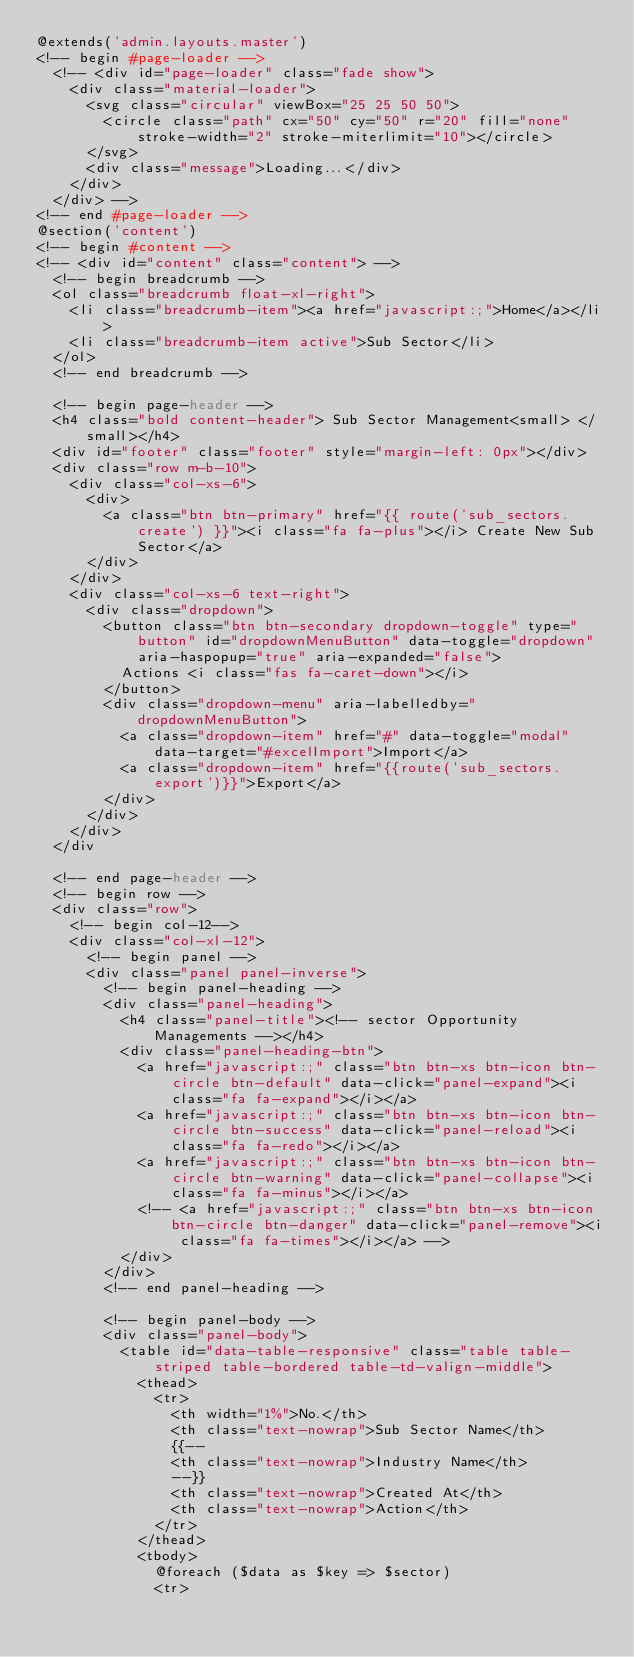Convert code to text. <code><loc_0><loc_0><loc_500><loc_500><_PHP_>@extends('admin.layouts.master')
<!-- begin #page-loader -->
  <!-- <div id="page-loader" class="fade show">
    <div class="material-loader">
      <svg class="circular" viewBox="25 25 50 50">
        <circle class="path" cx="50" cy="50" r="20" fill="none" stroke-width="2" stroke-miterlimit="10"></circle>
      </svg>
      <div class="message">Loading...</div>
    </div>
  </div> -->
<!-- end #page-loader -->
@section('content')
<!-- begin #content -->
<!-- <div id="content" class="content"> -->
  <!-- begin breadcrumb -->
  <ol class="breadcrumb float-xl-right">
    <li class="breadcrumb-item"><a href="javascript:;">Home</a></li>
    <li class="breadcrumb-item active">Sub Sector</li>
  </ol>
  <!-- end breadcrumb -->

  <!-- begin page-header -->
  <h4 class="bold content-header"> Sub Sector Management<small> </small></h4>
  <div id="footer" class="footer" style="margin-left: 0px"></div>
  <div class="row m-b-10">
    <div class="col-xs-6">
      <div>
        <a class="btn btn-primary" href="{{ route('sub_sectors.create') }}"><i class="fa fa-plus"></i> Create New Sub Sector</a>            
      </div>
    </div>
    <div class="col-xs-6 text-right">
      <div class="dropdown">
        <button class="btn btn-secondary dropdown-toggle" type="button" id="dropdownMenuButton" data-toggle="dropdown" aria-haspopup="true" aria-expanded="false">
          Actions <i class="fas fa-caret-down"></i>
        </button>
        <div class="dropdown-menu" aria-labelledby="dropdownMenuButton">
          <a class="dropdown-item" href="#" data-toggle="modal" data-target="#excelImport">Import</a>
          <a class="dropdown-item" href="{{route('sub_sectors.export')}}">Export</a>
        </div>
      </div>
    </div>
  </div
   
  <!-- end page-header -->
  <!-- begin row -->
  <div class="row">
    <!-- begin col-12-->
    <div class="col-xl-12">
      <!-- begin panel -->
      <div class="panel panel-inverse">
        <!-- begin panel-heading -->
        <div class="panel-heading">
          <h4 class="panel-title"><!-- sector Opportunity Managements --></h4>
          <div class="panel-heading-btn">
            <a href="javascript:;" class="btn btn-xs btn-icon btn-circle btn-default" data-click="panel-expand"><i class="fa fa-expand"></i></a>
            <a href="javascript:;" class="btn btn-xs btn-icon btn-circle btn-success" data-click="panel-reload"><i class="fa fa-redo"></i></a>
            <a href="javascript:;" class="btn btn-xs btn-icon btn-circle btn-warning" data-click="panel-collapse"><i class="fa fa-minus"></i></a>
            <!-- <a href="javascript:;" class="btn btn-xs btn-icon btn-circle btn-danger" data-click="panel-remove"><i class="fa fa-times"></i></a> -->
          </div>
        </div>
        <!-- end panel-heading -->

        <!-- begin panel-body -->
        <div class="panel-body">
          <table id="data-table-responsive" class="table table-striped table-bordered table-td-valign-middle">
            <thead>
              <tr>
                <th width="1%">No.</th>
                <th class="text-nowrap">Sub Sector Name</th>
                {{-- 
                <th class="text-nowrap">Industry Name</th>
                --}}
                <th class="text-nowrap">Created At</th>
                <th class="text-nowrap">Action</th>
              </tr>
            </thead>
            <tbody>
              @foreach ($data as $key => $sector)
              <tr></code> 